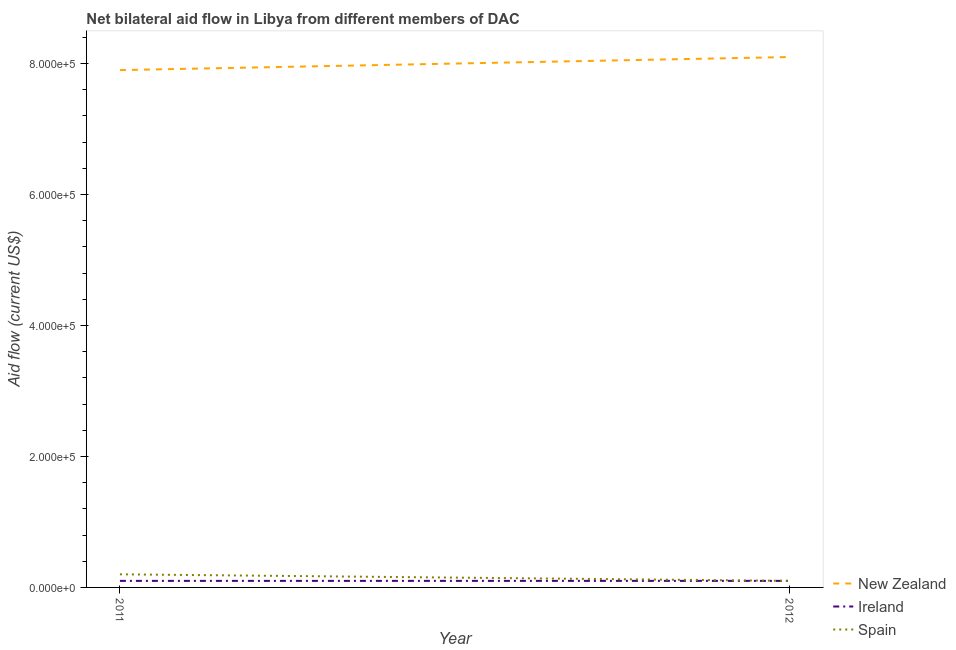Does the line corresponding to amount of aid provided by ireland intersect with the line corresponding to amount of aid provided by spain?
Keep it short and to the point. Yes. What is the amount of aid provided by new zealand in 2011?
Provide a succinct answer. 7.90e+05. Across all years, what is the maximum amount of aid provided by spain?
Offer a terse response. 2.00e+04. Across all years, what is the minimum amount of aid provided by new zealand?
Ensure brevity in your answer.  7.90e+05. In which year was the amount of aid provided by spain minimum?
Provide a succinct answer. 2012. What is the total amount of aid provided by new zealand in the graph?
Keep it short and to the point. 1.60e+06. What is the difference between the amount of aid provided by new zealand in 2011 and that in 2012?
Provide a short and direct response. -2.00e+04. What is the difference between the amount of aid provided by ireland in 2012 and the amount of aid provided by new zealand in 2011?
Give a very brief answer. -7.80e+05. What is the average amount of aid provided by spain per year?
Offer a terse response. 1.50e+04. In the year 2011, what is the difference between the amount of aid provided by new zealand and amount of aid provided by ireland?
Provide a short and direct response. 7.80e+05. What is the ratio of the amount of aid provided by new zealand in 2011 to that in 2012?
Your answer should be very brief. 0.98. Is the amount of aid provided by new zealand in 2011 less than that in 2012?
Your answer should be very brief. Yes. In how many years, is the amount of aid provided by spain greater than the average amount of aid provided by spain taken over all years?
Provide a short and direct response. 1. Is it the case that in every year, the sum of the amount of aid provided by new zealand and amount of aid provided by ireland is greater than the amount of aid provided by spain?
Offer a very short reply. Yes. Does the amount of aid provided by new zealand monotonically increase over the years?
Offer a very short reply. Yes. Is the amount of aid provided by spain strictly greater than the amount of aid provided by ireland over the years?
Keep it short and to the point. No. Is the amount of aid provided by new zealand strictly less than the amount of aid provided by spain over the years?
Ensure brevity in your answer.  No. How many lines are there?
Provide a succinct answer. 3. Does the graph contain any zero values?
Ensure brevity in your answer.  No. Where does the legend appear in the graph?
Provide a succinct answer. Bottom right. How many legend labels are there?
Provide a short and direct response. 3. How are the legend labels stacked?
Your answer should be compact. Vertical. What is the title of the graph?
Offer a terse response. Net bilateral aid flow in Libya from different members of DAC. Does "Ages 50+" appear as one of the legend labels in the graph?
Provide a succinct answer. No. What is the label or title of the X-axis?
Give a very brief answer. Year. What is the label or title of the Y-axis?
Provide a succinct answer. Aid flow (current US$). What is the Aid flow (current US$) of New Zealand in 2011?
Offer a terse response. 7.90e+05. What is the Aid flow (current US$) in Ireland in 2011?
Your answer should be compact. 10000. What is the Aid flow (current US$) of New Zealand in 2012?
Provide a short and direct response. 8.10e+05. What is the Aid flow (current US$) in Ireland in 2012?
Ensure brevity in your answer.  10000. What is the Aid flow (current US$) in Spain in 2012?
Your answer should be very brief. 10000. Across all years, what is the maximum Aid flow (current US$) of New Zealand?
Your response must be concise. 8.10e+05. Across all years, what is the minimum Aid flow (current US$) of New Zealand?
Keep it short and to the point. 7.90e+05. What is the total Aid flow (current US$) of New Zealand in the graph?
Provide a succinct answer. 1.60e+06. What is the difference between the Aid flow (current US$) of New Zealand in 2011 and that in 2012?
Keep it short and to the point. -2.00e+04. What is the difference between the Aid flow (current US$) of Spain in 2011 and that in 2012?
Your answer should be compact. 10000. What is the difference between the Aid flow (current US$) of New Zealand in 2011 and the Aid flow (current US$) of Ireland in 2012?
Offer a terse response. 7.80e+05. What is the difference between the Aid flow (current US$) in New Zealand in 2011 and the Aid flow (current US$) in Spain in 2012?
Provide a succinct answer. 7.80e+05. What is the average Aid flow (current US$) in Ireland per year?
Your response must be concise. 10000. What is the average Aid flow (current US$) in Spain per year?
Offer a terse response. 1.50e+04. In the year 2011, what is the difference between the Aid flow (current US$) in New Zealand and Aid flow (current US$) in Ireland?
Offer a terse response. 7.80e+05. In the year 2011, what is the difference between the Aid flow (current US$) in New Zealand and Aid flow (current US$) in Spain?
Give a very brief answer. 7.70e+05. In the year 2011, what is the difference between the Aid flow (current US$) in Ireland and Aid flow (current US$) in Spain?
Offer a terse response. -10000. In the year 2012, what is the difference between the Aid flow (current US$) in Ireland and Aid flow (current US$) in Spain?
Provide a succinct answer. 0. What is the ratio of the Aid flow (current US$) in New Zealand in 2011 to that in 2012?
Your response must be concise. 0.98. What is the difference between the highest and the second highest Aid flow (current US$) in Ireland?
Offer a terse response. 0. What is the difference between the highest and the lowest Aid flow (current US$) of Ireland?
Your response must be concise. 0. What is the difference between the highest and the lowest Aid flow (current US$) of Spain?
Offer a terse response. 10000. 